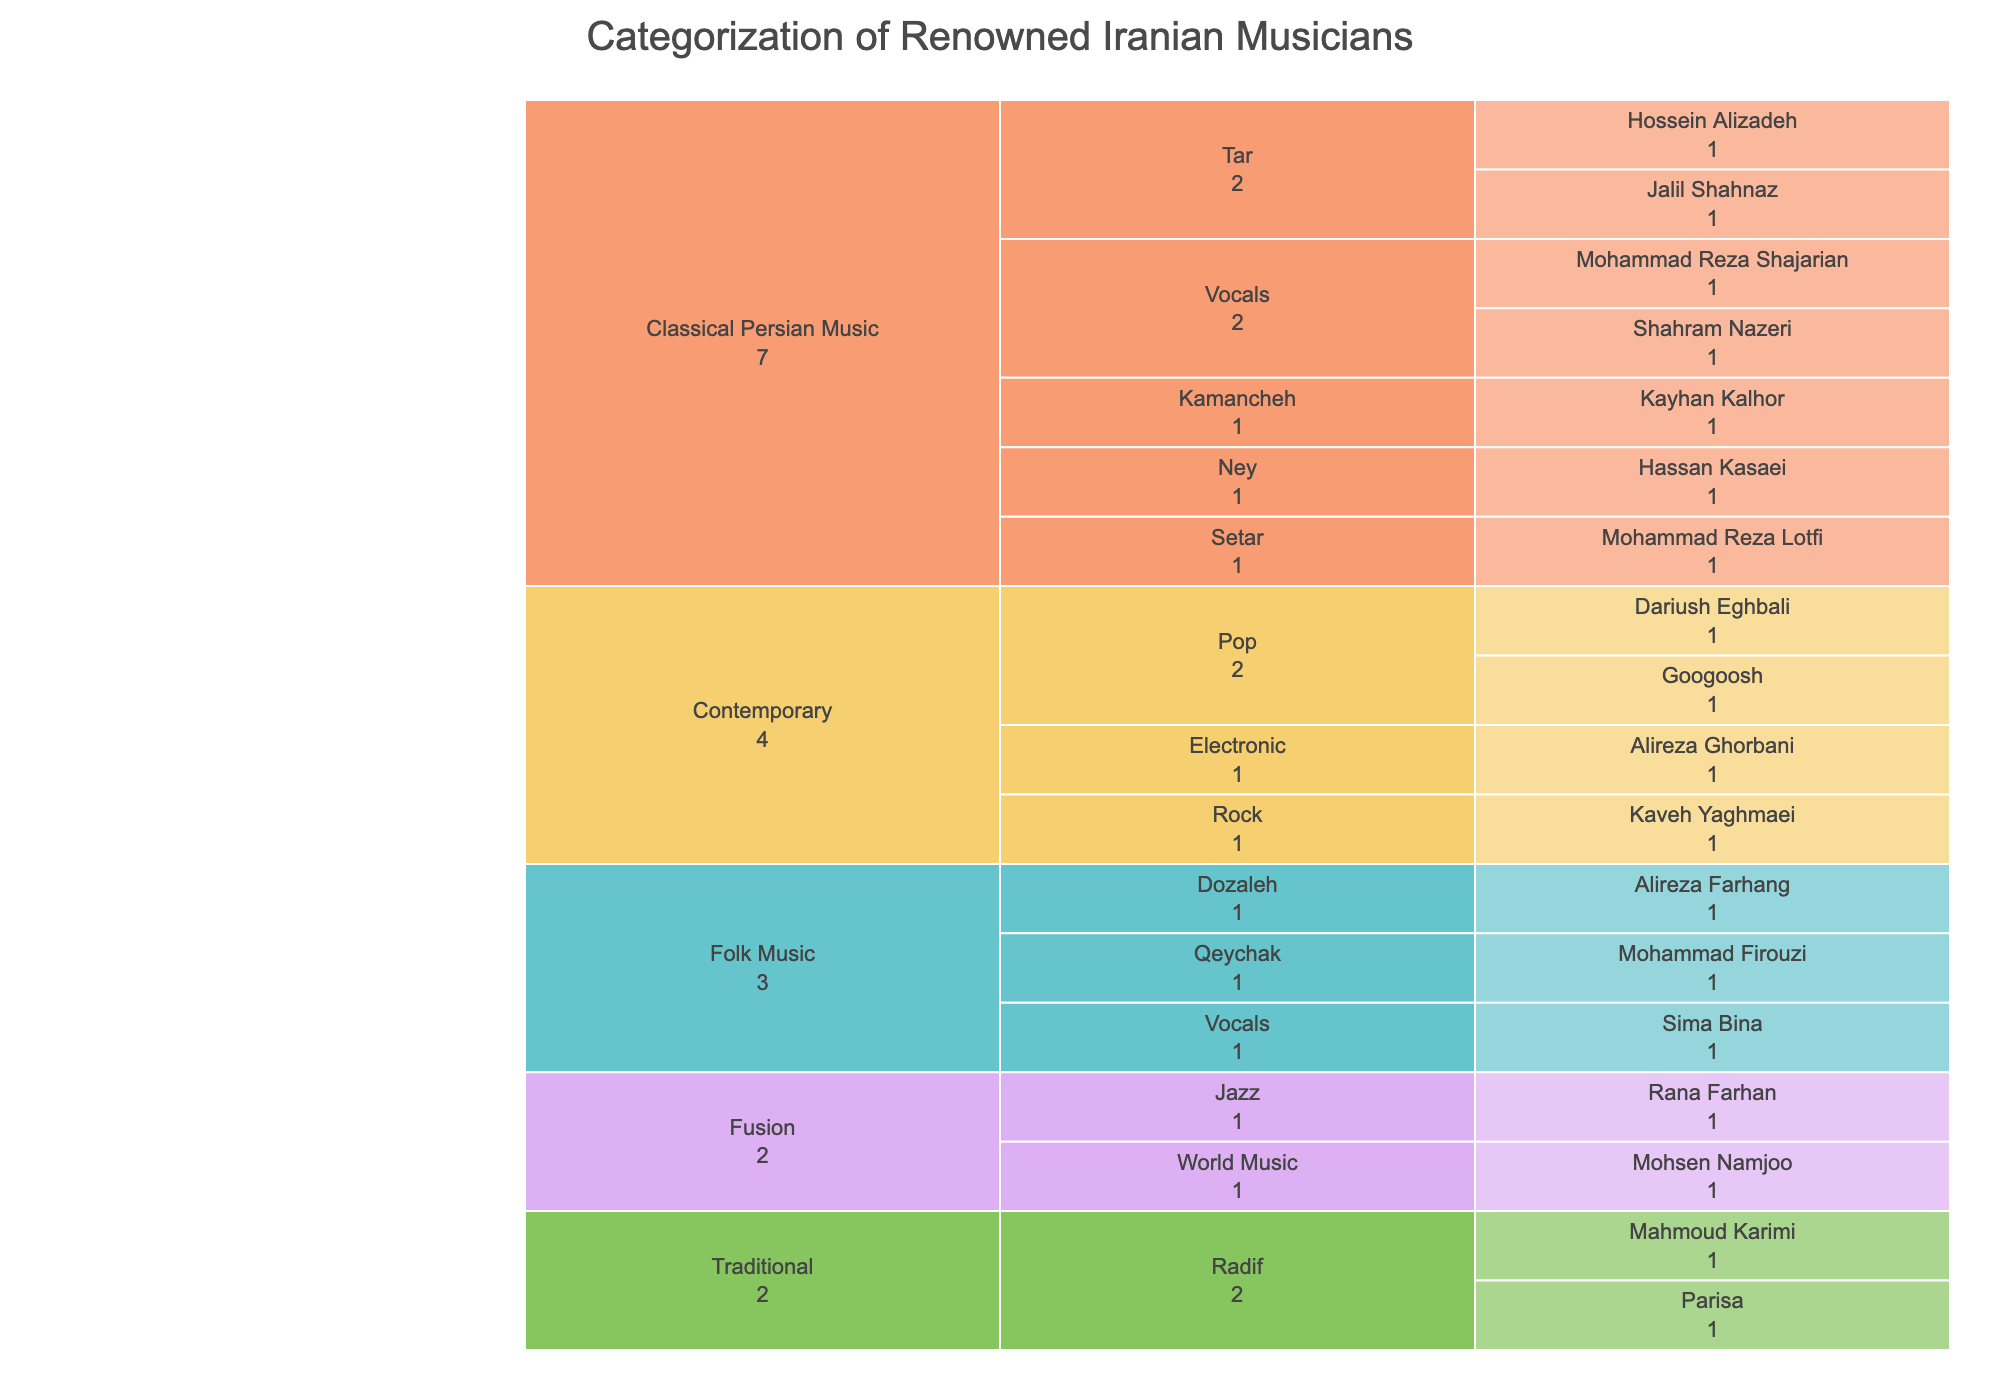What's the title of the figure? The title is typically found at the top of the chart and provides an overarching description of what the chart is about. In this case, it is stated as part of the icicle chart configuration.
Answer: Categorization of Renowned Iranian Musicians Which musician is listed under the 'Ney' subcategory in Classical Persian Music? Look at the section of the chart labeled 'Classical Persian Music', find the subcategory 'Ney', and observe the musician listed under it.
Answer: Hassan Kasaei How many musicians are categorized under 'Vocals' across all categories? Navigate through each top-level category and count the musicians listed under the 'Vocals' subcategory in each of them.
Answer: Four Which category has the most subcategories, and how many are there? Inspect each top-level category and count the number of subcategories they contain. Compare these counts to determine which is the highest.
Answer: Classical Persian Music, five How many musicians are there in the 'Contemporary' category? Locate the 'Contemporary' category and count all the musicians listed under its subcategories.
Answer: Four Who is the only musician listed in the 'Jazz' subcategory within the 'Fusion' category? Navigate to the 'Fusion' category, locate the 'Jazz' subcategory and observe the musician listed under it.
Answer: Rana Farhan Is there any musician listed in both 'Classical Persian Music' and 'Contemporary'? Compare the names under 'Classical Persian Music' and 'Contemporary' categories to see if any name appears in both.
Answer: No What is the total number of musicians listed under the 'Folk Music' category? Count all the musicians listed under the various subcategories of the 'Folk Music' top-level category.
Answer: Three Name the musicians categorized under 'Tar' in 'Classical Persian Music'. Locate the 'Tar' subcategory within the 'Classical Persian Music' category and list all the musicians under it.
Answer: Hossein Alizadeh, Jalil Shahnaz Comparing 'Traditional' and 'Fusion' categories, which has more musicians, and by how many? Count the musicians in 'Traditional' and 'Fusion' categories independently, then find the difference between these counts.
Answer: Traditional has two more musicians than Fusion 